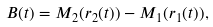<formula> <loc_0><loc_0><loc_500><loc_500>B ( t ) = M _ { 2 } ( r _ { 2 } ( t ) ) - M _ { 1 } ( r _ { 1 } ( t ) ) ,</formula> 